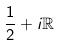<formula> <loc_0><loc_0><loc_500><loc_500>\frac { 1 } { 2 } + i \mathbb { R }</formula> 